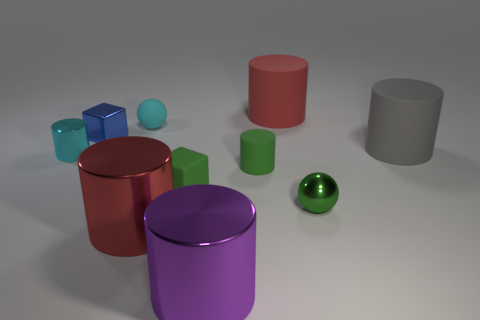Subtract all gray cylinders. How many cylinders are left? 5 Subtract all small green rubber cylinders. How many cylinders are left? 5 Subtract all brown cylinders. Subtract all brown balls. How many cylinders are left? 6 Subtract all spheres. How many objects are left? 8 Add 9 small shiny balls. How many small shiny balls exist? 10 Subtract 0 red balls. How many objects are left? 10 Subtract all tiny red rubber cubes. Subtract all gray rubber objects. How many objects are left? 9 Add 6 tiny green shiny spheres. How many tiny green shiny spheres are left? 7 